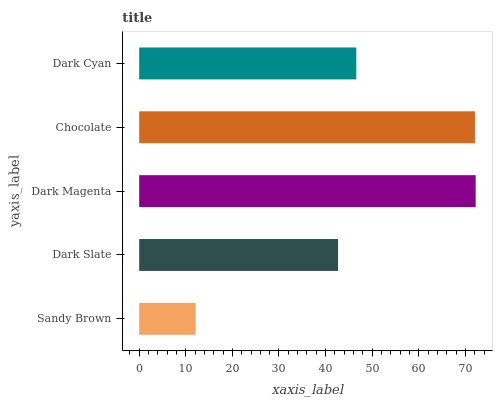Is Sandy Brown the minimum?
Answer yes or no. Yes. Is Dark Magenta the maximum?
Answer yes or no. Yes. Is Dark Slate the minimum?
Answer yes or no. No. Is Dark Slate the maximum?
Answer yes or no. No. Is Dark Slate greater than Sandy Brown?
Answer yes or no. Yes. Is Sandy Brown less than Dark Slate?
Answer yes or no. Yes. Is Sandy Brown greater than Dark Slate?
Answer yes or no. No. Is Dark Slate less than Sandy Brown?
Answer yes or no. No. Is Dark Cyan the high median?
Answer yes or no. Yes. Is Dark Cyan the low median?
Answer yes or no. Yes. Is Dark Magenta the high median?
Answer yes or no. No. Is Dark Slate the low median?
Answer yes or no. No. 